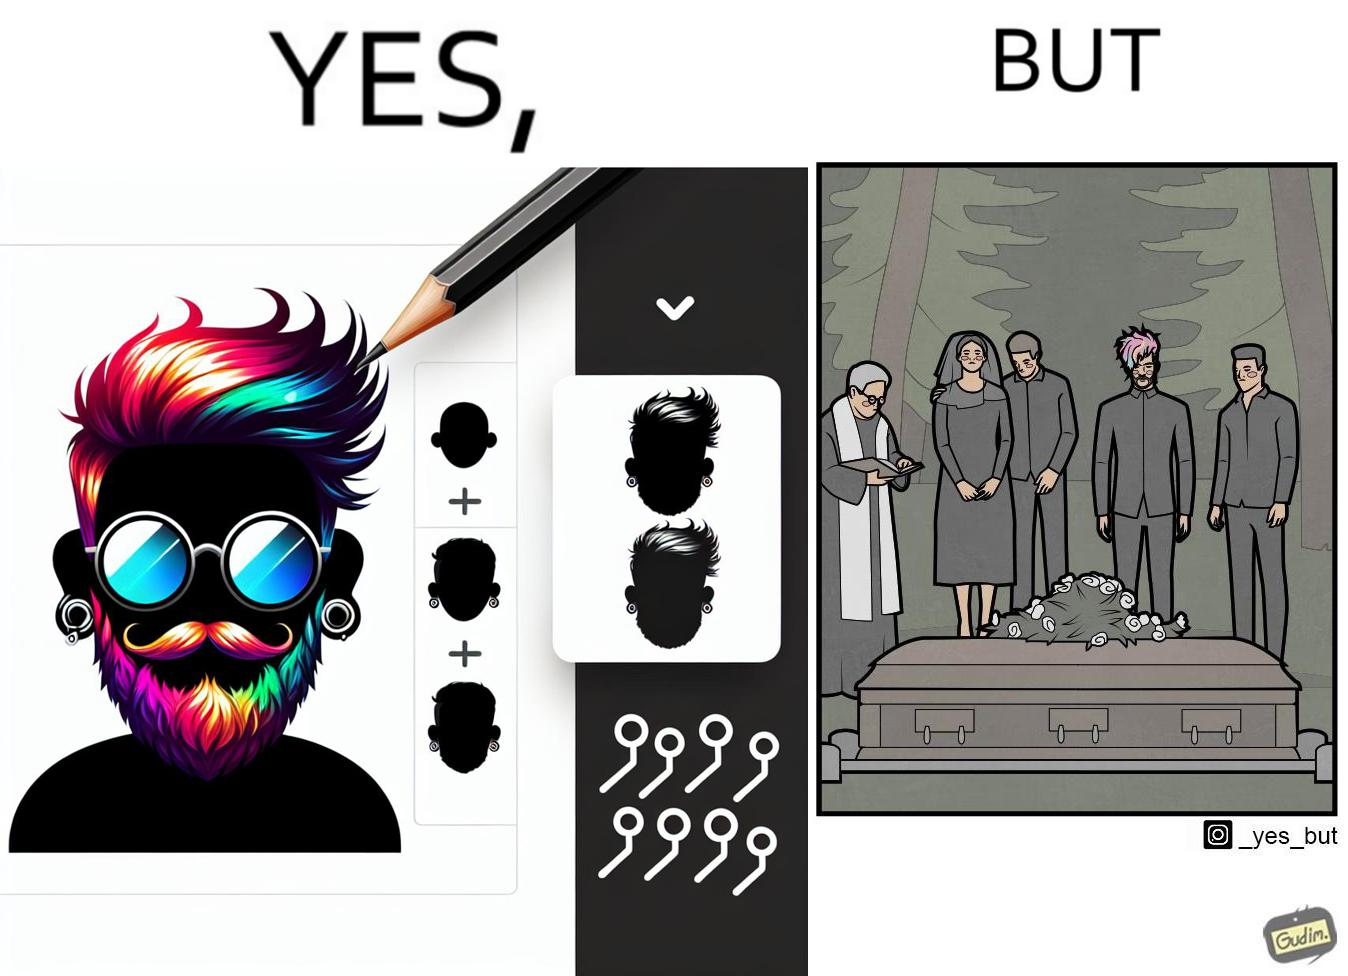Why is this image considered satirical? The image is ironic, because in the second image it is shown that a group of people is attending someone's death ceremony but one of them is shown as wrongly dressed for that place in first image, his visual appearances doesn't shows his feeling of mourning 